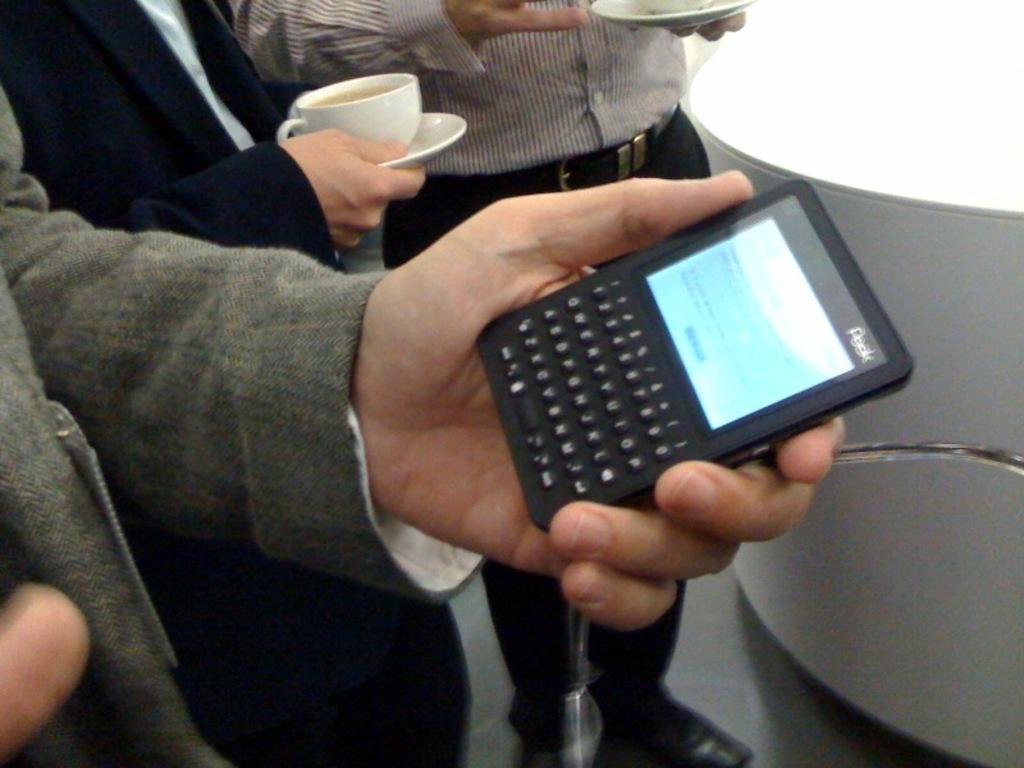Can you describe this image briefly? There are three persons in this image. The man standing at the right side is holding a cup in his hand. In the center man wearing a black colour suit is holding a tea cup and saucer in his hand. At the left side the man is holding a mobile in his hand. At the right side there is a white colour table. 